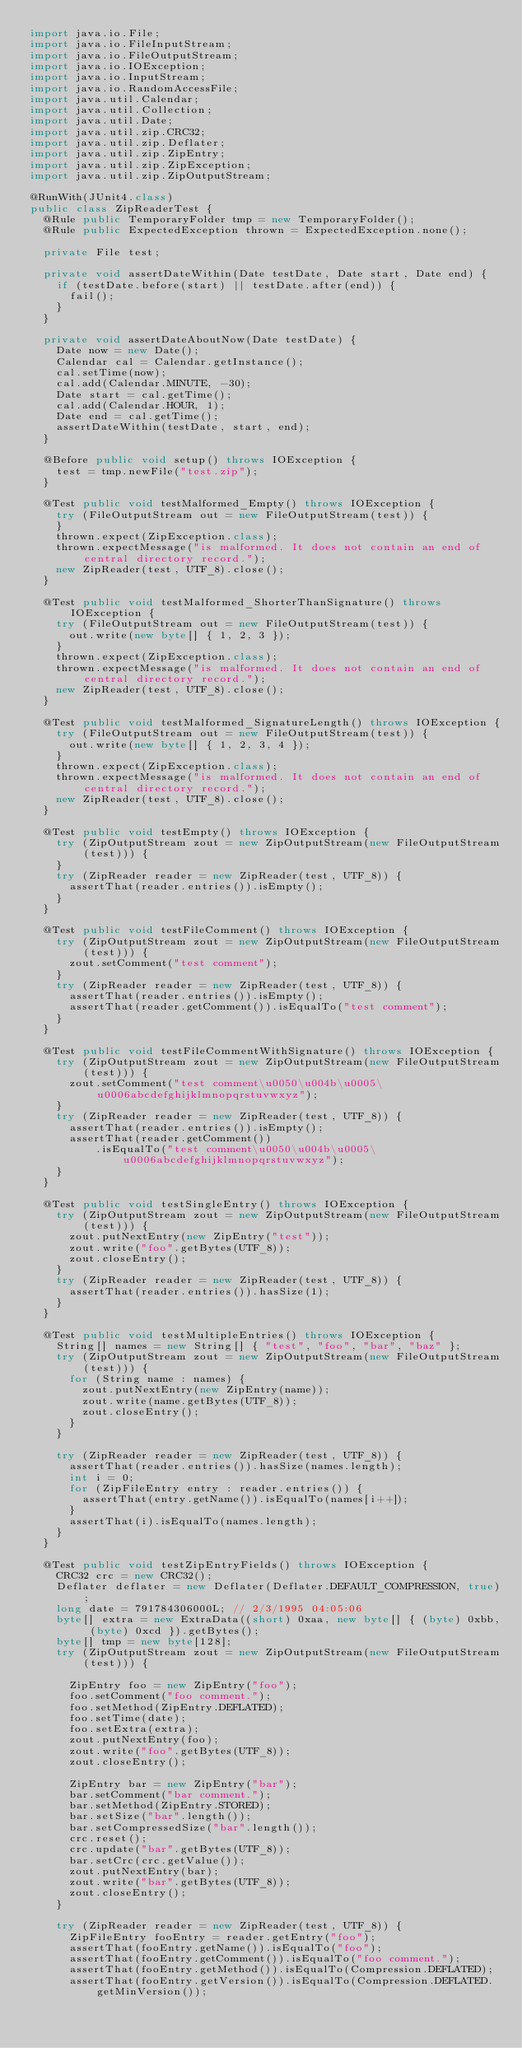<code> <loc_0><loc_0><loc_500><loc_500><_Java_>import java.io.File;
import java.io.FileInputStream;
import java.io.FileOutputStream;
import java.io.IOException;
import java.io.InputStream;
import java.io.RandomAccessFile;
import java.util.Calendar;
import java.util.Collection;
import java.util.Date;
import java.util.zip.CRC32;
import java.util.zip.Deflater;
import java.util.zip.ZipEntry;
import java.util.zip.ZipException;
import java.util.zip.ZipOutputStream;

@RunWith(JUnit4.class)
public class ZipReaderTest {
  @Rule public TemporaryFolder tmp = new TemporaryFolder();
  @Rule public ExpectedException thrown = ExpectedException.none();

  private File test;

  private void assertDateWithin(Date testDate, Date start, Date end) {
    if (testDate.before(start) || testDate.after(end)) {
      fail();
    }
  }

  private void assertDateAboutNow(Date testDate) {
    Date now = new Date();
    Calendar cal = Calendar.getInstance();
    cal.setTime(now);
    cal.add(Calendar.MINUTE, -30);
    Date start = cal.getTime();
    cal.add(Calendar.HOUR, 1);
    Date end = cal.getTime();
    assertDateWithin(testDate, start, end);
  }

  @Before public void setup() throws IOException {
    test = tmp.newFile("test.zip");
  }

  @Test public void testMalformed_Empty() throws IOException {
    try (FileOutputStream out = new FileOutputStream(test)) {
    }
    thrown.expect(ZipException.class);
    thrown.expectMessage("is malformed. It does not contain an end of central directory record.");
    new ZipReader(test, UTF_8).close();
  }

  @Test public void testMalformed_ShorterThanSignature() throws IOException {
    try (FileOutputStream out = new FileOutputStream(test)) {
      out.write(new byte[] { 1, 2, 3 });
    }
    thrown.expect(ZipException.class);
    thrown.expectMessage("is malformed. It does not contain an end of central directory record.");
    new ZipReader(test, UTF_8).close();
  }

  @Test public void testMalformed_SignatureLength() throws IOException {
    try (FileOutputStream out = new FileOutputStream(test)) {
      out.write(new byte[] { 1, 2, 3, 4 });
    }
    thrown.expect(ZipException.class);
    thrown.expectMessage("is malformed. It does not contain an end of central directory record.");
    new ZipReader(test, UTF_8).close();
  }

  @Test public void testEmpty() throws IOException {
    try (ZipOutputStream zout = new ZipOutputStream(new FileOutputStream(test))) {
    }
    try (ZipReader reader = new ZipReader(test, UTF_8)) {
      assertThat(reader.entries()).isEmpty();
    }
  }

  @Test public void testFileComment() throws IOException {
    try (ZipOutputStream zout = new ZipOutputStream(new FileOutputStream(test))) {
      zout.setComment("test comment");
    }
    try (ZipReader reader = new ZipReader(test, UTF_8)) {
      assertThat(reader.entries()).isEmpty();
      assertThat(reader.getComment()).isEqualTo("test comment");
    }
  }

  @Test public void testFileCommentWithSignature() throws IOException {
    try (ZipOutputStream zout = new ZipOutputStream(new FileOutputStream(test))) {
      zout.setComment("test comment\u0050\u004b\u0005\u0006abcdefghijklmnopqrstuvwxyz");
    }
    try (ZipReader reader = new ZipReader(test, UTF_8)) {
      assertThat(reader.entries()).isEmpty();
      assertThat(reader.getComment())
          .isEqualTo("test comment\u0050\u004b\u0005\u0006abcdefghijklmnopqrstuvwxyz");
    }
  }

  @Test public void testSingleEntry() throws IOException {
    try (ZipOutputStream zout = new ZipOutputStream(new FileOutputStream(test))) {
      zout.putNextEntry(new ZipEntry("test"));
      zout.write("foo".getBytes(UTF_8));
      zout.closeEntry();
    }
    try (ZipReader reader = new ZipReader(test, UTF_8)) {
      assertThat(reader.entries()).hasSize(1);
    }
  }

  @Test public void testMultipleEntries() throws IOException {
    String[] names = new String[] { "test", "foo", "bar", "baz" };
    try (ZipOutputStream zout = new ZipOutputStream(new FileOutputStream(test))) {
      for (String name : names) {
        zout.putNextEntry(new ZipEntry(name));
        zout.write(name.getBytes(UTF_8));
        zout.closeEntry();
      }
    }

    try (ZipReader reader = new ZipReader(test, UTF_8)) {
      assertThat(reader.entries()).hasSize(names.length);
      int i = 0;
      for (ZipFileEntry entry : reader.entries()) {
        assertThat(entry.getName()).isEqualTo(names[i++]);
      }
      assertThat(i).isEqualTo(names.length);
    }
  }

  @Test public void testZipEntryFields() throws IOException {
    CRC32 crc = new CRC32();
    Deflater deflater = new Deflater(Deflater.DEFAULT_COMPRESSION, true);
    long date = 791784306000L; // 2/3/1995 04:05:06
    byte[] extra = new ExtraData((short) 0xaa, new byte[] { (byte) 0xbb, (byte) 0xcd }).getBytes();
    byte[] tmp = new byte[128];
    try (ZipOutputStream zout = new ZipOutputStream(new FileOutputStream(test))) {

      ZipEntry foo = new ZipEntry("foo");
      foo.setComment("foo comment.");
      foo.setMethod(ZipEntry.DEFLATED);
      foo.setTime(date);
      foo.setExtra(extra);
      zout.putNextEntry(foo);
      zout.write("foo".getBytes(UTF_8));
      zout.closeEntry();

      ZipEntry bar = new ZipEntry("bar");
      bar.setComment("bar comment.");
      bar.setMethod(ZipEntry.STORED);
      bar.setSize("bar".length());
      bar.setCompressedSize("bar".length());
      crc.reset();
      crc.update("bar".getBytes(UTF_8));
      bar.setCrc(crc.getValue());
      zout.putNextEntry(bar);
      zout.write("bar".getBytes(UTF_8));
      zout.closeEntry();
    }

    try (ZipReader reader = new ZipReader(test, UTF_8)) {
      ZipFileEntry fooEntry = reader.getEntry("foo");
      assertThat(fooEntry.getName()).isEqualTo("foo");
      assertThat(fooEntry.getComment()).isEqualTo("foo comment.");
      assertThat(fooEntry.getMethod()).isEqualTo(Compression.DEFLATED);
      assertThat(fooEntry.getVersion()).isEqualTo(Compression.DEFLATED.getMinVersion());</code> 